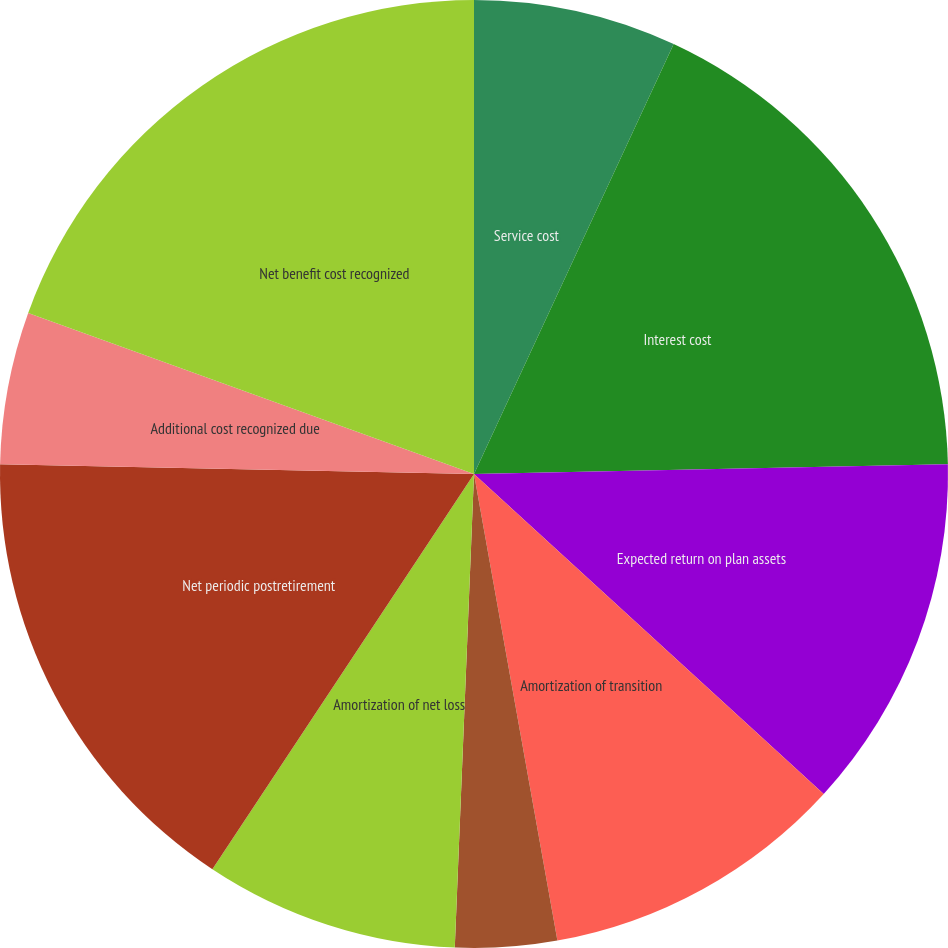Convert chart. <chart><loc_0><loc_0><loc_500><loc_500><pie_chart><fcel>Service cost<fcel>Interest cost<fcel>Expected return on plan assets<fcel>Amortization of transition<fcel>Amortization of prior service<fcel>Amortization of net loss<fcel>Net periodic postretirement<fcel>Additional cost recognized due<fcel>Net benefit cost recognized<fcel>Discount rate for year-end<nl><fcel>6.92%<fcel>17.75%<fcel>12.12%<fcel>10.39%<fcel>3.46%<fcel>8.66%<fcel>16.02%<fcel>5.19%<fcel>19.48%<fcel>0.0%<nl></chart> 